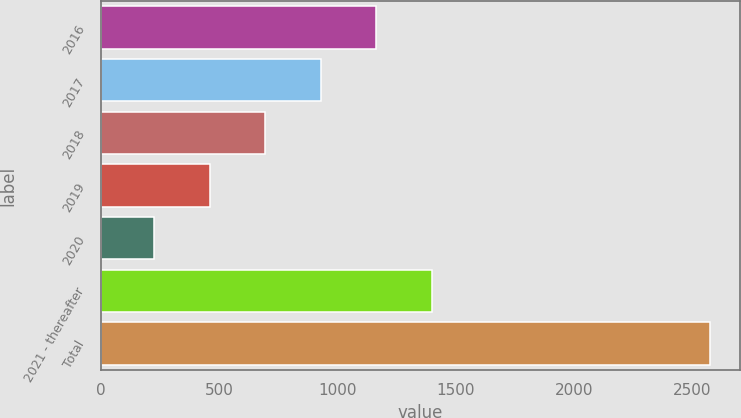<chart> <loc_0><loc_0><loc_500><loc_500><bar_chart><fcel>2016<fcel>2017<fcel>2018<fcel>2019<fcel>2020<fcel>2021 - thereafter<fcel>Total<nl><fcel>1165.6<fcel>930.7<fcel>695.8<fcel>460.9<fcel>226<fcel>1400.5<fcel>2575<nl></chart> 